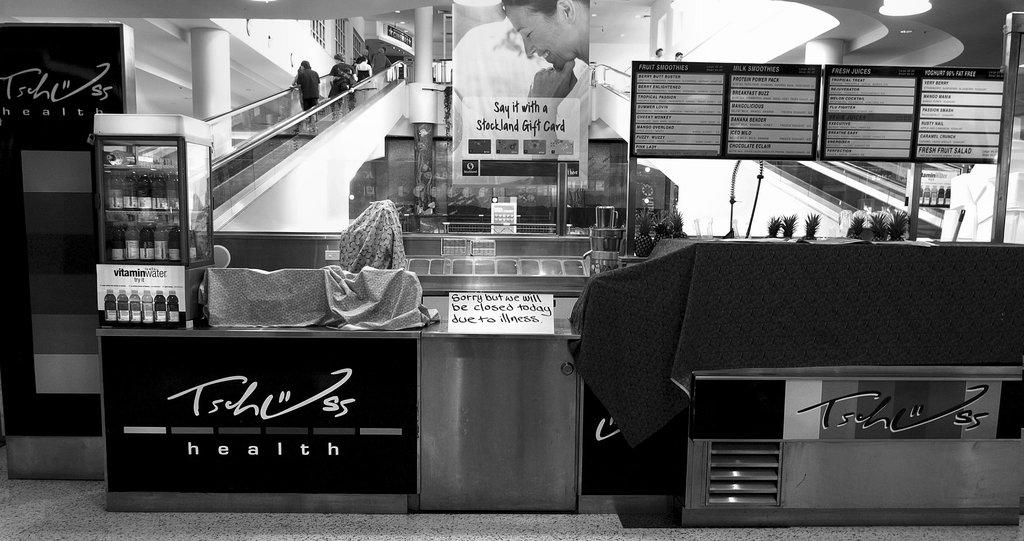What is the color scheme of the image? The image is black and white. What can be seen in the foreground of the image? There is a stall in the foreground of the image. What is visible in the background of the image? There is a staircase in the background of the image. What are the people in the image doing? People are climbing the staircase. What type of rock can be seen in the image? There is no rock present in the image; it features a stall in the foreground and a staircase in the background. How many boys are visible in the image? The provided facts do not mention the number or gender of the people in the image, so it cannot be determined from the image alone. 